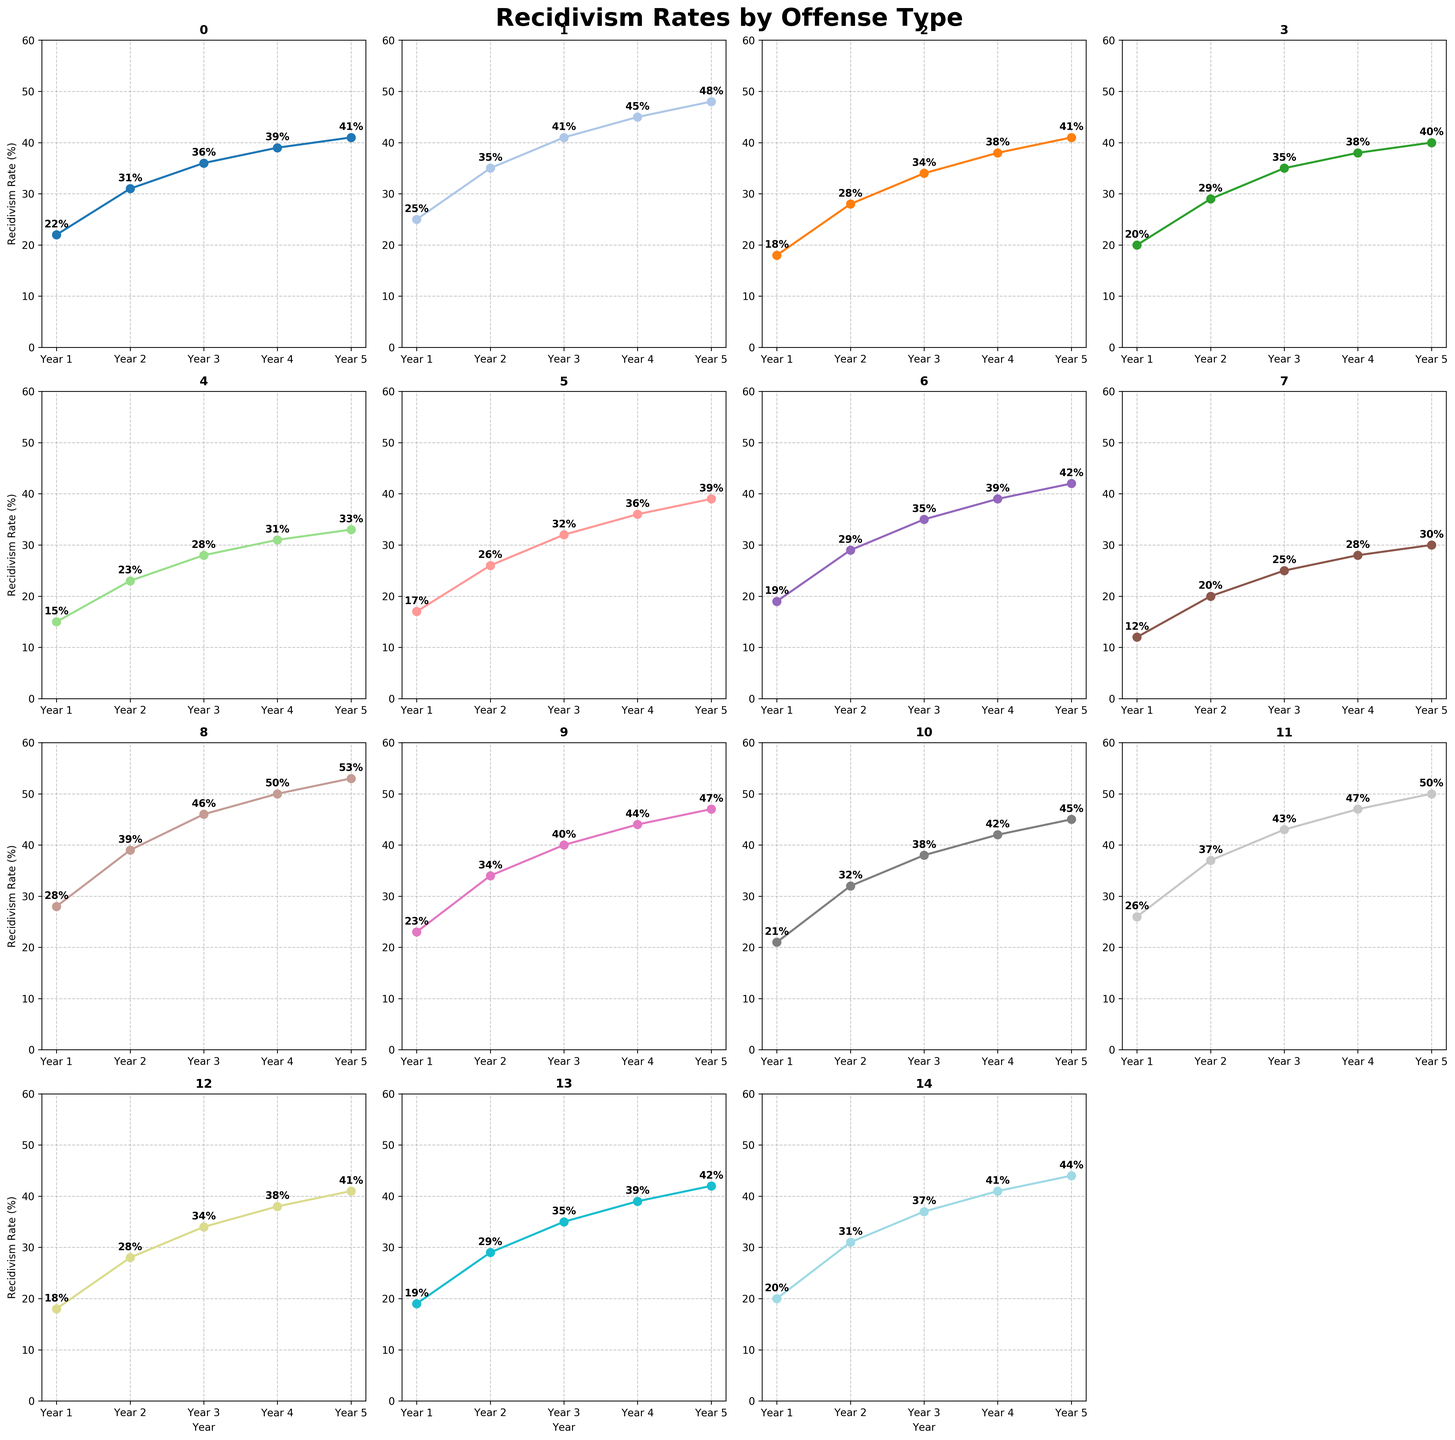Which offense type has the highest recidivism rate in Year 5? To find the offense type with the highest recidivism rate in Year 5, I look at the last data point in each subplot. 'Burglary' has the highest value at 53%.
Answer: Burglary Which offense types have a recidivism rate of exactly 31% in Year 2? I search for the data points in Year 2 that have a value of 31%. Both 'Drug offenses' and 'Domestic violence' match this criterion.
Answer: Drug offenses, Domestic violence What's the difference in recidivism rate between 'Violent crimes' and 'Theft' in Year 3? 'Violent crimes' in Year 3 has a rate of 34%, and 'Theft' has 43%. The difference is calculated as 43 - 34 = 9%.
Answer: 9% Which offense type shows the smallest increase in recidivism rate from Year 1 to Year 5? I calculate the increase for each offense type by subtracting the Year 1 value from the Year 5 value. 'Sex offenses' increased from 12% to 30%, a difference of 18%, which is the smallest.
Answer: Sex offenses Compare the recidivism rate trends of 'Assault' and 'Robbery'. Which one has a consistently higher rate? I check the values for 'Assault' (21%, 32%, 38%, 42%, 45%) and 'Robbery' (23%, 34%, 40%, 44%, 47%). 'Robbery' has consistently higher rates in every year.
Answer: Robbery What is the average recidivism rate for 'Public order offenses' over the 5 years? Add values: 20 + 29 + 35 + 38 + 40 = 162. The average is 162/5 = 32.4%.
Answer: 32.4% Which offense type shows the steepest increase in recidivism rate between Year 1 and Year 2? I calculate the increase for Year 1 to Year 2 for each offense type and find the steepest one. 'Burglary' increased from 28% to 39%, an increase of 11%, the steepest.
Answer: Burglary What is the median recidivism rate in Year 4 for all offense types? List the Year 4 rates: 39, 45, 38, 38, 31, 36, 39, 28, 50, 44, 42, 47, 38, 39, 41. Sorting these values yields: 28, 31, 36, 38, 38, 38, 39, 39, 39, 41, 42, 44, 45, 47, 50. The median is the middle value, 39.
Answer: 39% How many offense types have recidivism rates above 40% in Year 5? I count the rates for Year 5 that are above 40%. There are 8 offense types: 'Drug offenses', 'Property crimes', 'Violent crimes', 'Weapons offenses', 'Burglary', 'Robbery', 'Assault', 'Theft'.
Answer: 8 Which graph has the highest final data point not exceeding 40%, and what is the value? I look for the highest Year 5 value not exceeding 40%. 'DUI/DWI' and 'Public order offenses' both have values exactly at 40%.
Answer: Public order offenses, DUI/DWI (both 40%) 